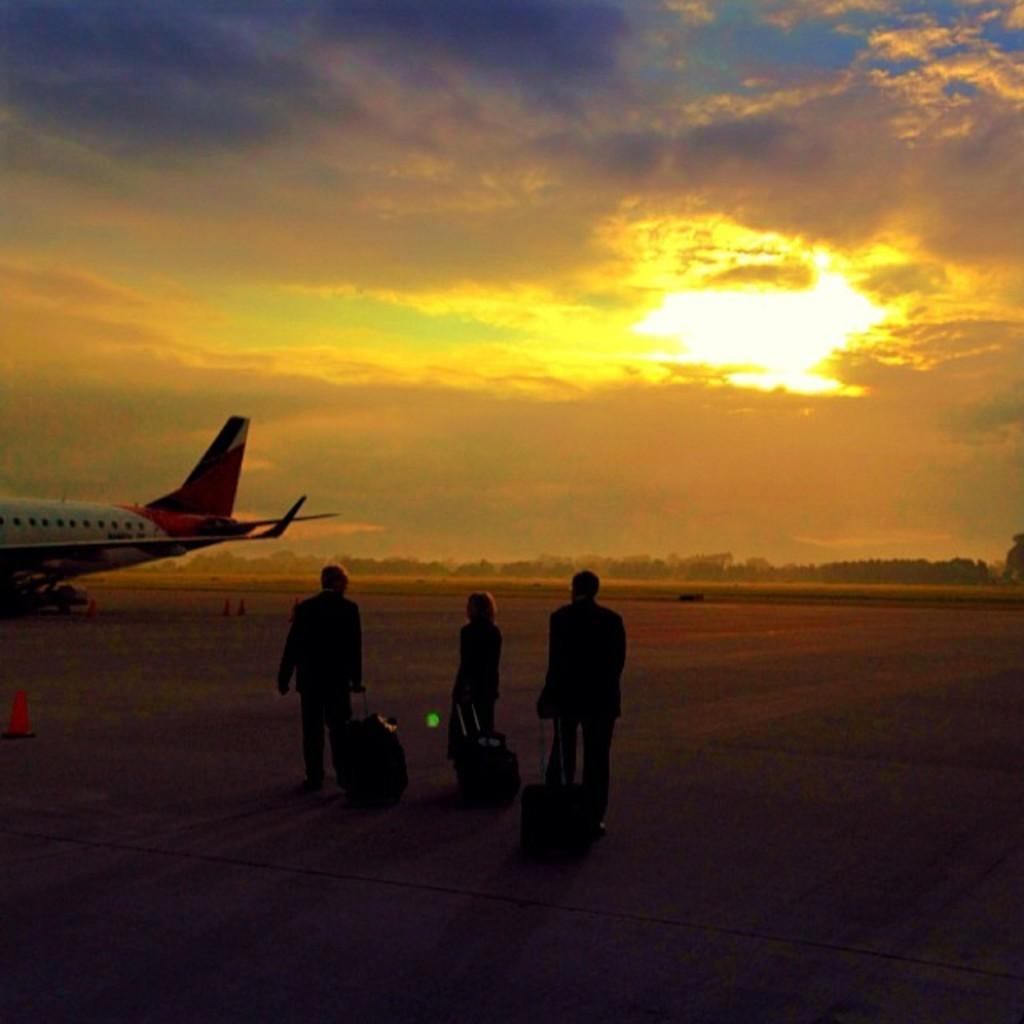How would you summarize this image in a sentence or two? In this image we can see persons walking on the road and holding suitcases in their hands, traffic cones, aeroplane, trees and sky with clouds. 